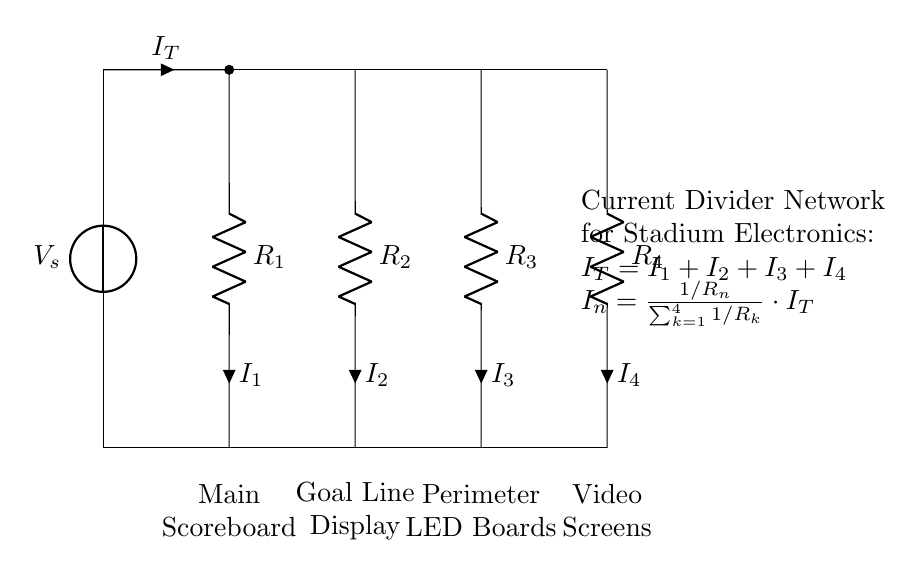What is the total current entering the network? The total current entering the network is represented by I_T, which is the sum of all individual currents flowing through the branches. According to the current divider formula, I_T = I_1 + I_2 + I_3 + I_4.
Answer: I_T What is the resistance value of the main scoreboard? The resistance associated with the main scoreboard is represented as R_1 in the circuit diagram. The label next to it indicates this connection.
Answer: R_1 How many branches are in the current divider network? The circuit shows four resistors connected in parallel, indicating four branches through which the current divides.
Answer: Four What is the formula for calculating the individual currents? The individual currents I_n can be calculated using the formula I_n = 1/R_n / (sum of 1/R_k for all branches) multiplied by the total current I_T. This formula comes from the principles of current division in parallel circuits.
Answer: I_n = 1/R_n * I_T / (sum of 1/R_k) Which component corresponds to the video screens? The component corresponding to the video screens is identified as R_4 in the circuit diagram. The label next to it makes this clear.
Answer: R_4 If R_2 has a resistance value of 10 ohms and I_T is 20 amps, what is I_2? Using the current divider formula for I_2, we can calculate it as follows: I_2 = (1/R_2) / (sum of 1/R_k) * I_T. Assuming the other resistances are known, this requires substituting the given values into the formula and calculating the result. If all other resistances are equal, I_2 = (0.1 / (0.1*4)) * 20, resulting in I_2 = 5 amps (specific values for R_1, R_3, and R_4 would adjust this).
Answer: 5 amps 